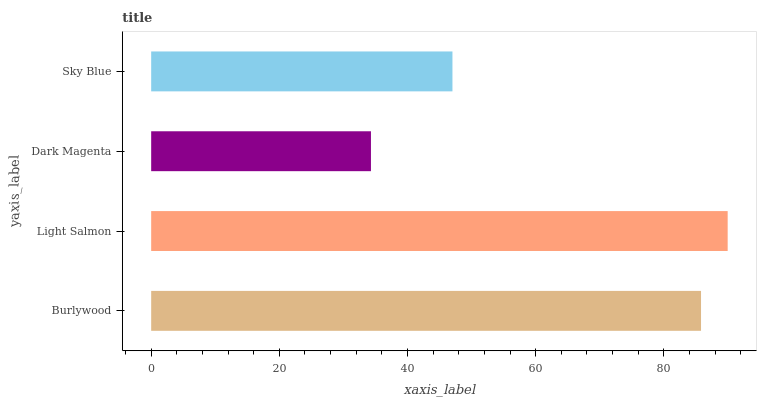Is Dark Magenta the minimum?
Answer yes or no. Yes. Is Light Salmon the maximum?
Answer yes or no. Yes. Is Light Salmon the minimum?
Answer yes or no. No. Is Dark Magenta the maximum?
Answer yes or no. No. Is Light Salmon greater than Dark Magenta?
Answer yes or no. Yes. Is Dark Magenta less than Light Salmon?
Answer yes or no. Yes. Is Dark Magenta greater than Light Salmon?
Answer yes or no. No. Is Light Salmon less than Dark Magenta?
Answer yes or no. No. Is Burlywood the high median?
Answer yes or no. Yes. Is Sky Blue the low median?
Answer yes or no. Yes. Is Sky Blue the high median?
Answer yes or no. No. Is Burlywood the low median?
Answer yes or no. No. 